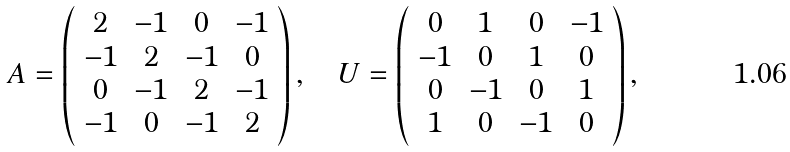Convert formula to latex. <formula><loc_0><loc_0><loc_500><loc_500>A = \left ( \begin{array} { c c c c } 2 & - 1 & 0 & - 1 \\ - 1 & 2 & - 1 & 0 \\ 0 & - 1 & 2 & - 1 \\ - 1 & 0 & - 1 & 2 \end{array} \right ) , \quad U = \left ( \begin{array} { c c c c } 0 & 1 & 0 & - 1 \\ - 1 & 0 & 1 & 0 \\ 0 & - 1 & 0 & 1 \\ 1 & 0 & - 1 & 0 \end{array} \right ) ,</formula> 